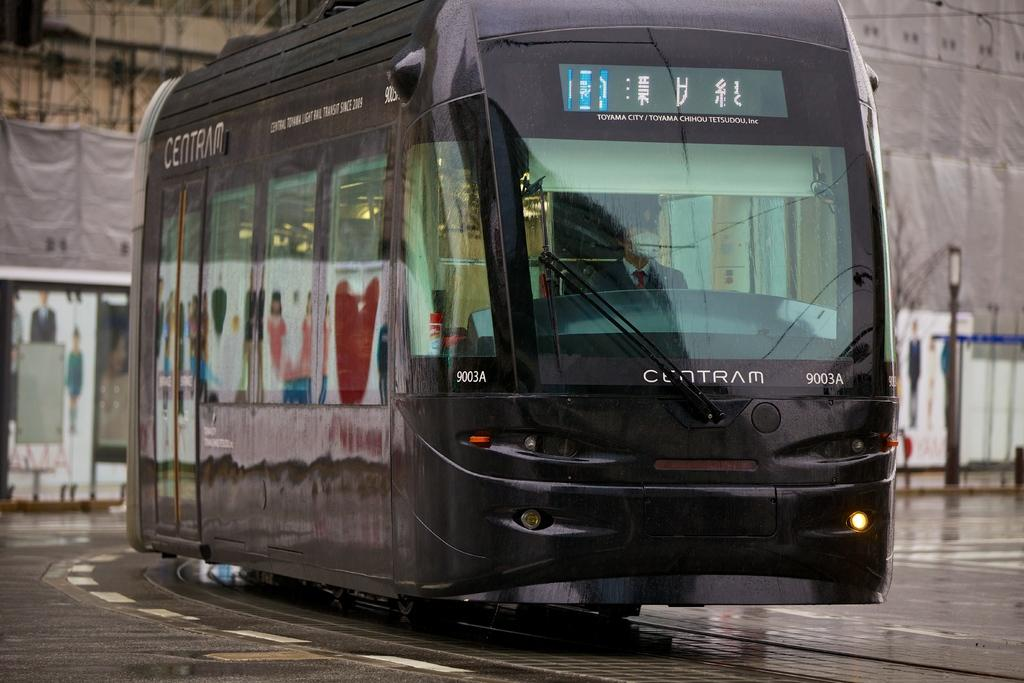What type of vehicle is in the front of the image? There is a black color bus in the front of the image. What can be seen in the background of the image? There is a dry tree and buildings in the background of the image. Can you describe the cloth visible in the background? The cloth visible in the background is not described in the provided facts. How does the bus embark on a voyage in the image? The bus does not embark on a voyage in the image; it is stationary. Can you hear the cry of any animals in the image? There is no mention of animals or their cries in the provided facts. 